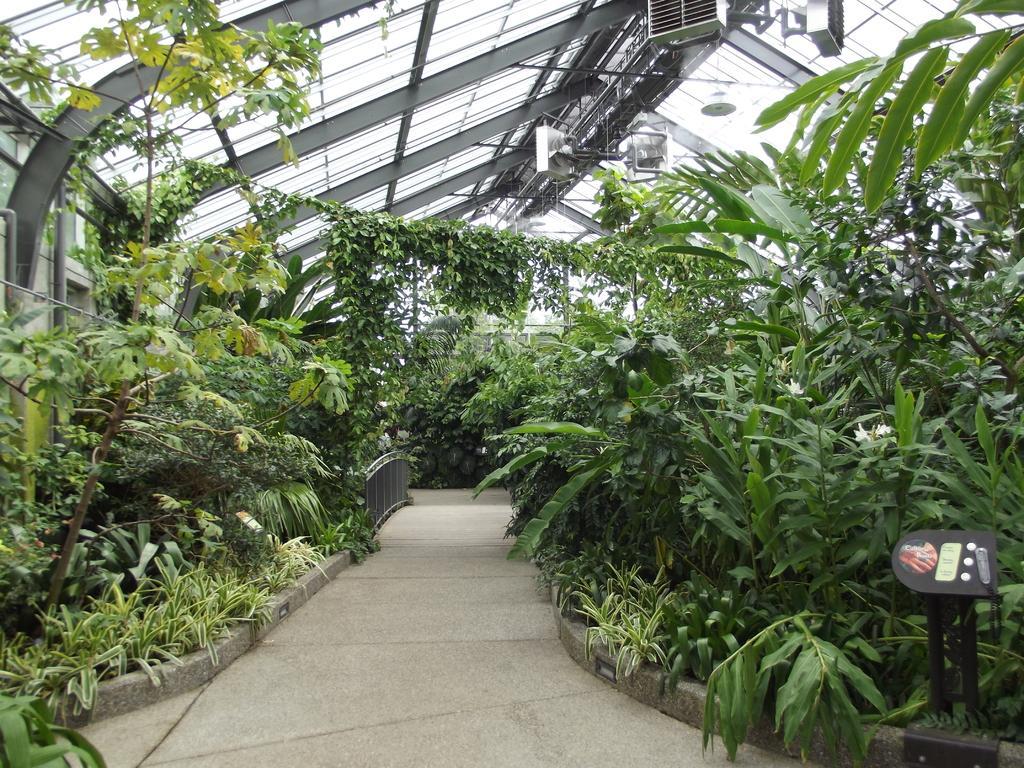Could you give a brief overview of what you see in this image? In the foreground of this image, there is a pavement and on either side, there are plants and trees. In the background, there is a railing. On the top, there is the glass ceiling and few objects. On the right bottom, there is a black object. 